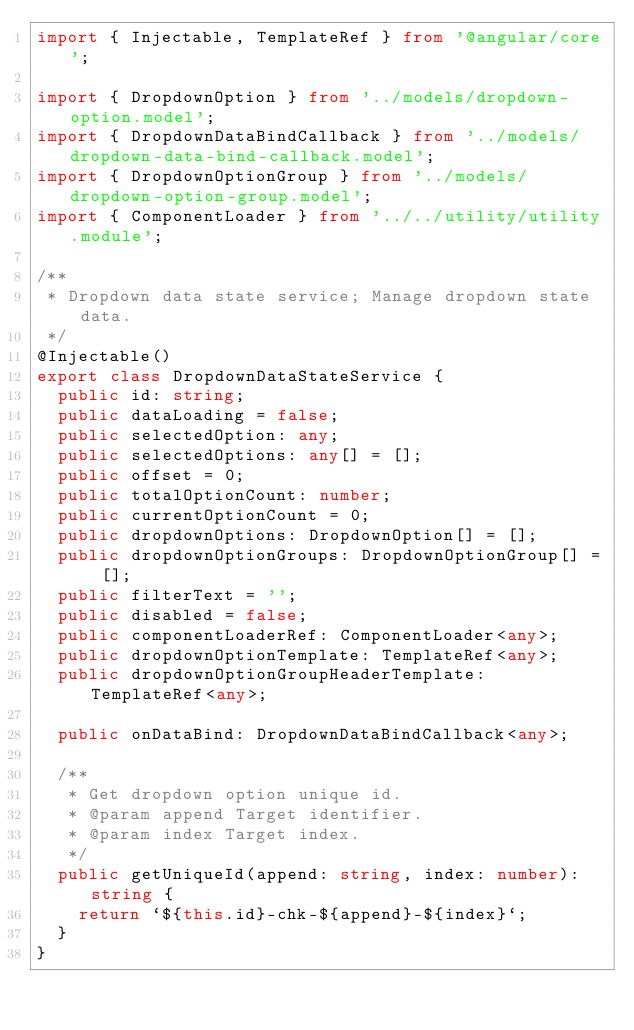Convert code to text. <code><loc_0><loc_0><loc_500><loc_500><_TypeScript_>import { Injectable, TemplateRef } from '@angular/core';

import { DropdownOption } from '../models/dropdown-option.model';
import { DropdownDataBindCallback } from '../models/dropdown-data-bind-callback.model';
import { DropdownOptionGroup } from '../models/dropdown-option-group.model';
import { ComponentLoader } from '../../utility/utility.module';

/**
 * Dropdown data state service; Manage dropdown state data.
 */
@Injectable()
export class DropdownDataStateService {
  public id: string;
  public dataLoading = false;
  public selectedOption: any;
  public selectedOptions: any[] = [];
  public offset = 0;
  public totalOptionCount: number;
  public currentOptionCount = 0;
  public dropdownOptions: DropdownOption[] = [];
  public dropdownOptionGroups: DropdownOptionGroup[] = [];
  public filterText = '';
  public disabled = false;
  public componentLoaderRef: ComponentLoader<any>;
  public dropdownOptionTemplate: TemplateRef<any>;
  public dropdownOptionGroupHeaderTemplate: TemplateRef<any>;

  public onDataBind: DropdownDataBindCallback<any>;

  /**
   * Get dropdown option unique id.
   * @param append Target identifier.
   * @param index Target index.
   */
  public getUniqueId(append: string, index: number): string {
    return `${this.id}-chk-${append}-${index}`;
  }
}
</code> 